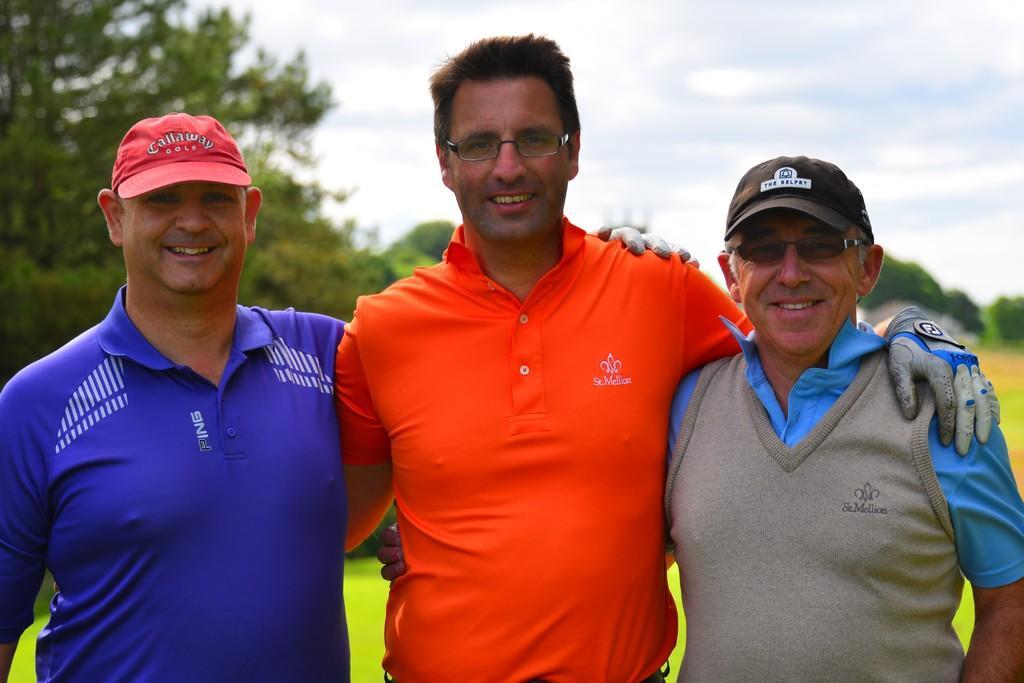Could you give a brief overview of what you see in this image? In this image there is the sky towards the top of the image, there are trees towards the right of the image, there is a tree towards the left of the image, there is grass towards the bottom of the image, there are three men standing towards the bottom of the image, there are two men wearing spectacles, there are two men wearing caps. 